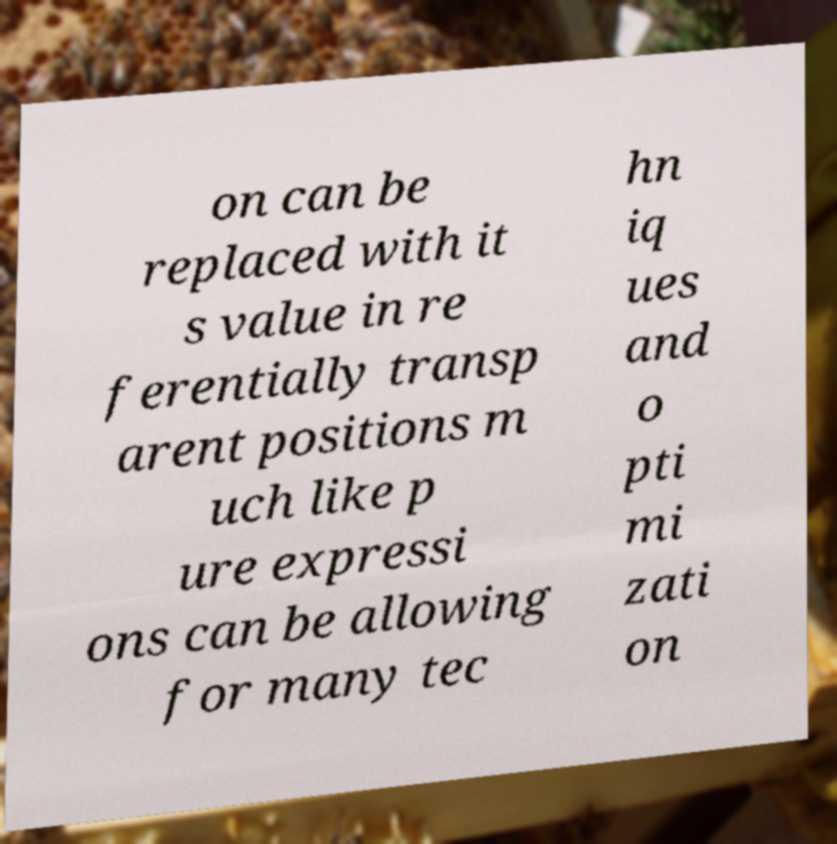Could you extract and type out the text from this image? on can be replaced with it s value in re ferentially transp arent positions m uch like p ure expressi ons can be allowing for many tec hn iq ues and o pti mi zati on 